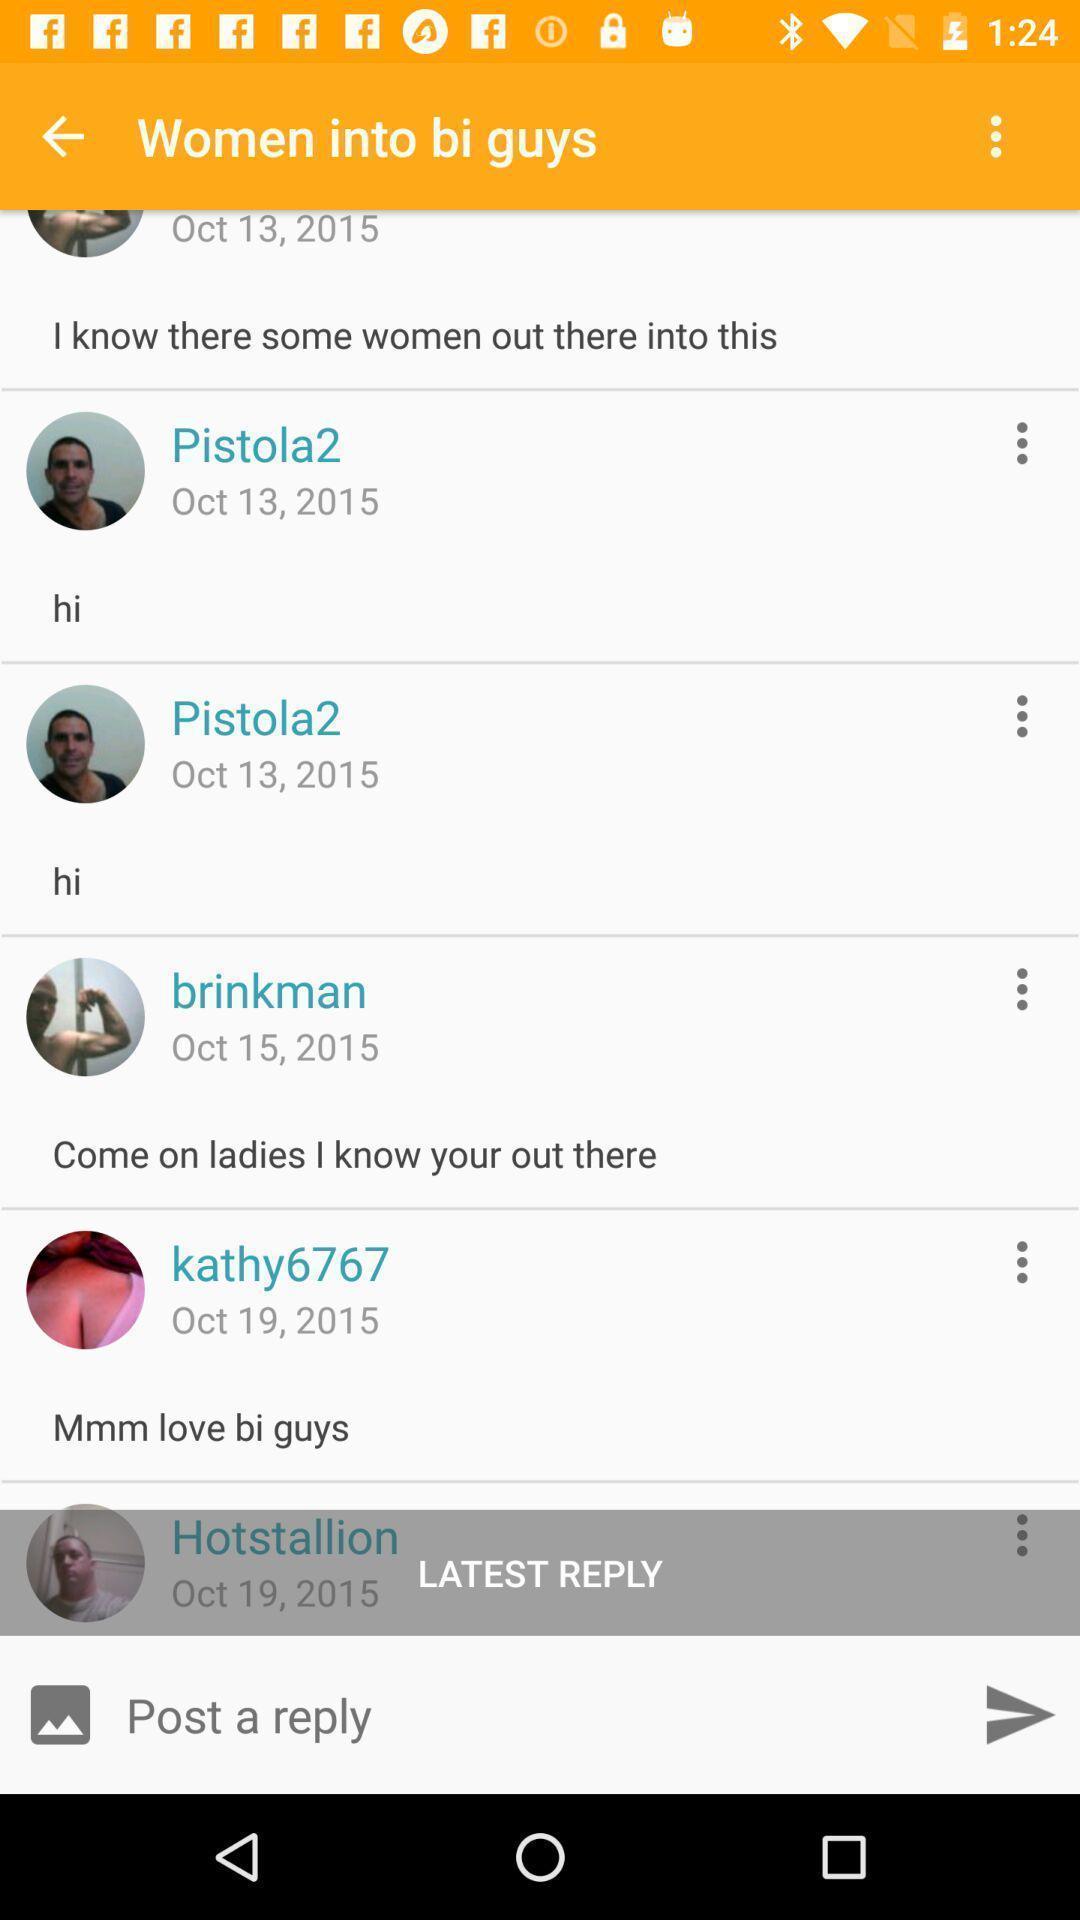Describe the visual elements of this screenshot. Screen shows a reply option. 